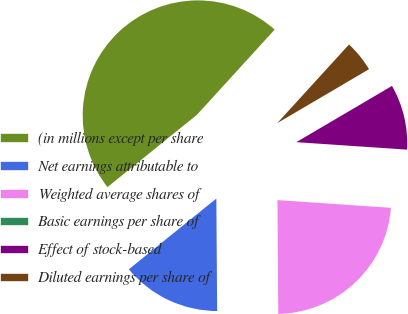Convert chart to OTSL. <chart><loc_0><loc_0><loc_500><loc_500><pie_chart><fcel>(in millions except per share<fcel>Net earnings attributable to<fcel>Weighted average shares of<fcel>Basic earnings per share of<fcel>Effect of stock-based<fcel>Diluted earnings per share of<nl><fcel>47.59%<fcel>14.29%<fcel>23.8%<fcel>0.01%<fcel>9.53%<fcel>4.77%<nl></chart> 